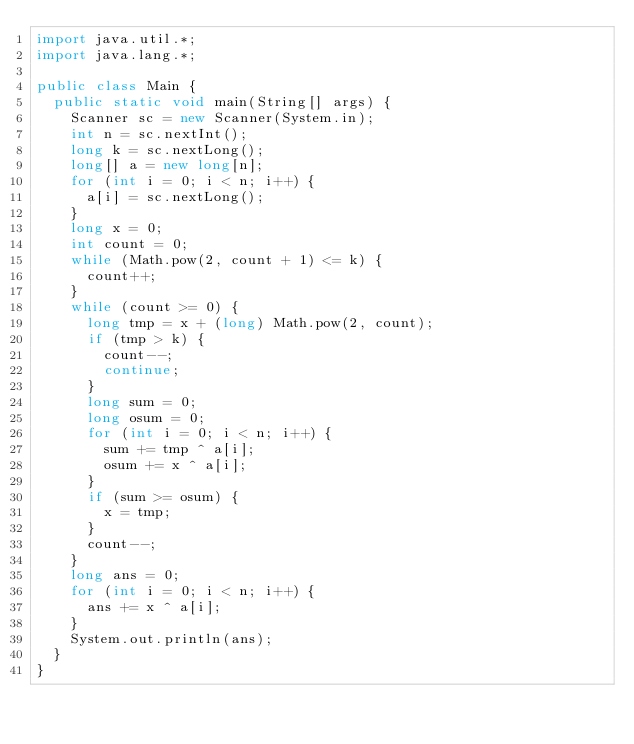Convert code to text. <code><loc_0><loc_0><loc_500><loc_500><_Java_>import java.util.*;
import java.lang.*;

public class Main {
	public static void main(String[] args) {
		Scanner sc = new Scanner(System.in);
		int n = sc.nextInt();
		long k = sc.nextLong();
		long[] a = new long[n];
		for (int i = 0; i < n; i++) {
			a[i] = sc.nextLong();
		}
		long x = 0;
		int count = 0;
		while (Math.pow(2, count + 1) <= k) {
			count++;
		}
		while (count >= 0) {
			long tmp = x + (long) Math.pow(2, count);
			if (tmp > k) {
				count--;
				continue;
			}
			long sum = 0;
			long osum = 0;
			for (int i = 0; i < n; i++) {
				sum += tmp ^ a[i];
				osum += x ^ a[i];
			}
			if (sum >= osum) {
				x = tmp;
			}
			count--;
		}
		long ans = 0;
		for (int i = 0; i < n; i++) {
			ans += x ^ a[i];
		}
		System.out.println(ans);
	}
}</code> 